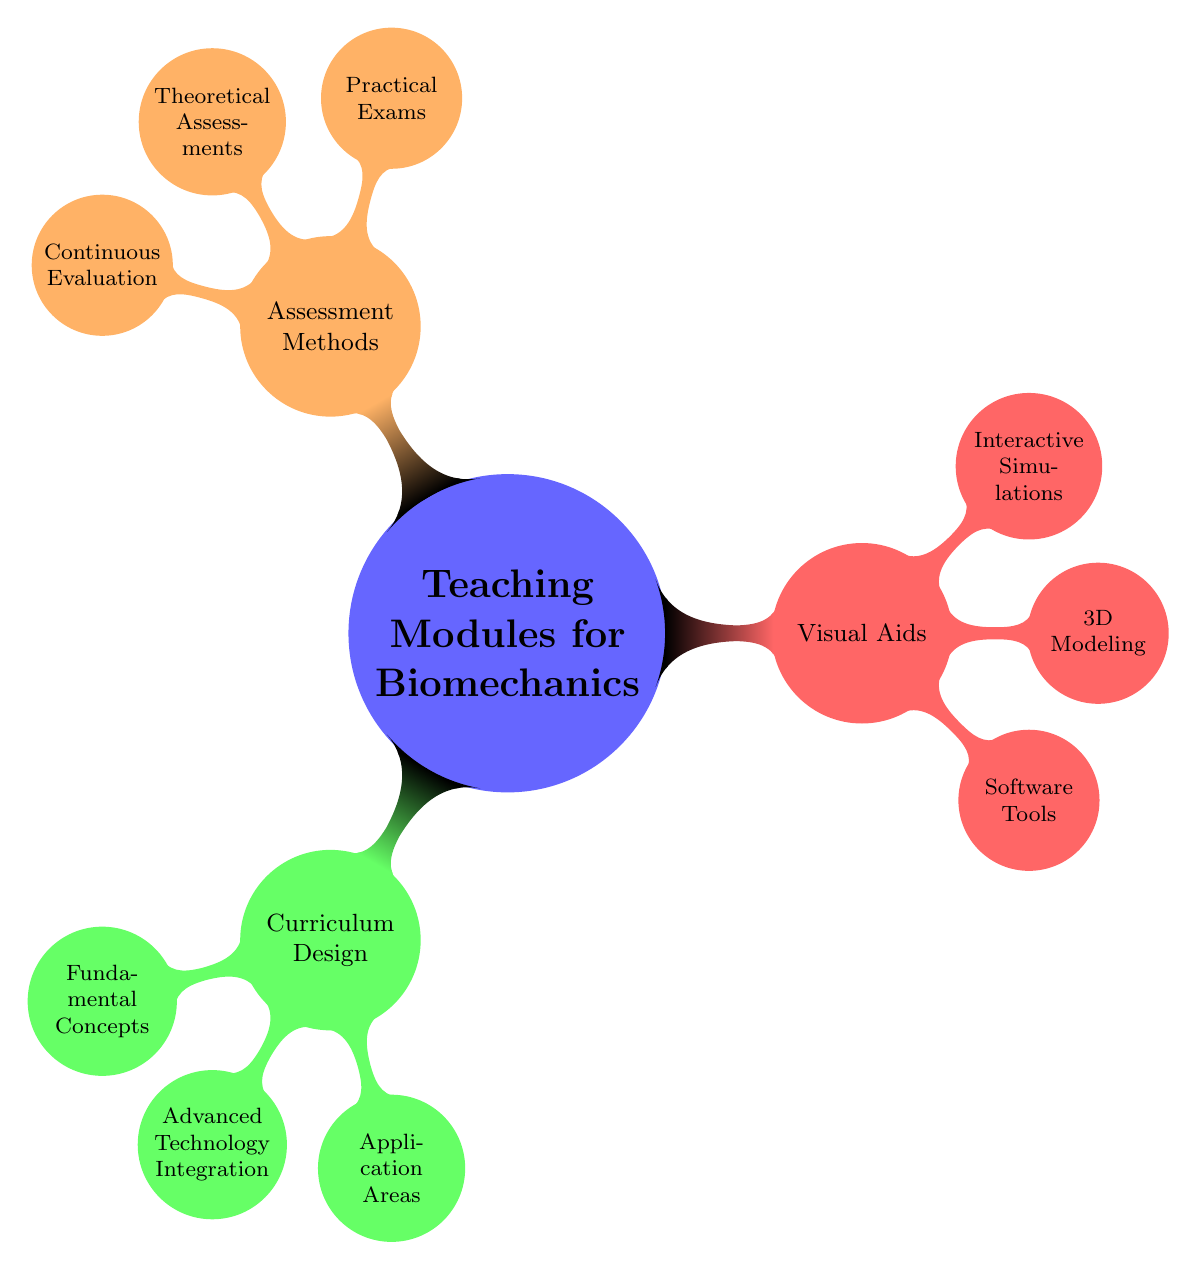What are the three main categories of teaching modules for biomechanics? The diagram shows three main categories branching from the central concept "Teaching Modules for Biomechanics." These categories are "Curriculum Design," "Visual Aids," and "Assessment Methods."
Answer: Curriculum Design, Visual Aids, Assessment Methods How many nodes are there under "Curriculum Design"? Under "Curriculum Design," there are three child nodes: "Fundamental Concepts," "Advanced Technology Integration," and "Application Areas." Counting these gives a total of three nodes.
Answer: 3 What is one of the software tools mentioned in the visual aids? The visual aids section includes child nodes like "Software Tools," which lists items such as "MATLAB," "SIMM," and "OpenSim." A single example can be taken as "MATLAB."
Answer: MATLAB Which assessment method involves ongoing performance measures? Under the "Assessment Methods" section, "Continuous Evaluation" is specifically mentioned as a method used for ongoing or periodic assessment of students.
Answer: Continuous Evaluation What are the three types of assessments listed under "Assessment Methods"? When analyzing the "Assessment Methods" section, it splits into three specific subcategories: "Practical Exams," "Theoretical Assessments," and "Continuous Evaluation." Together these represent the different types of assessments.
Answer: Practical Exams, Theoretical Assessments, Continuous Evaluation What category includes "Motion Capture Systems"? "Motion Capture Systems" is listed under "Advanced Technology Integration," which is a subcategory of "Curriculum Design." This relation shows it is primarily focused on the curriculum-related technology integration aspect of biomechanics.
Answer: Advanced Technology Integration 